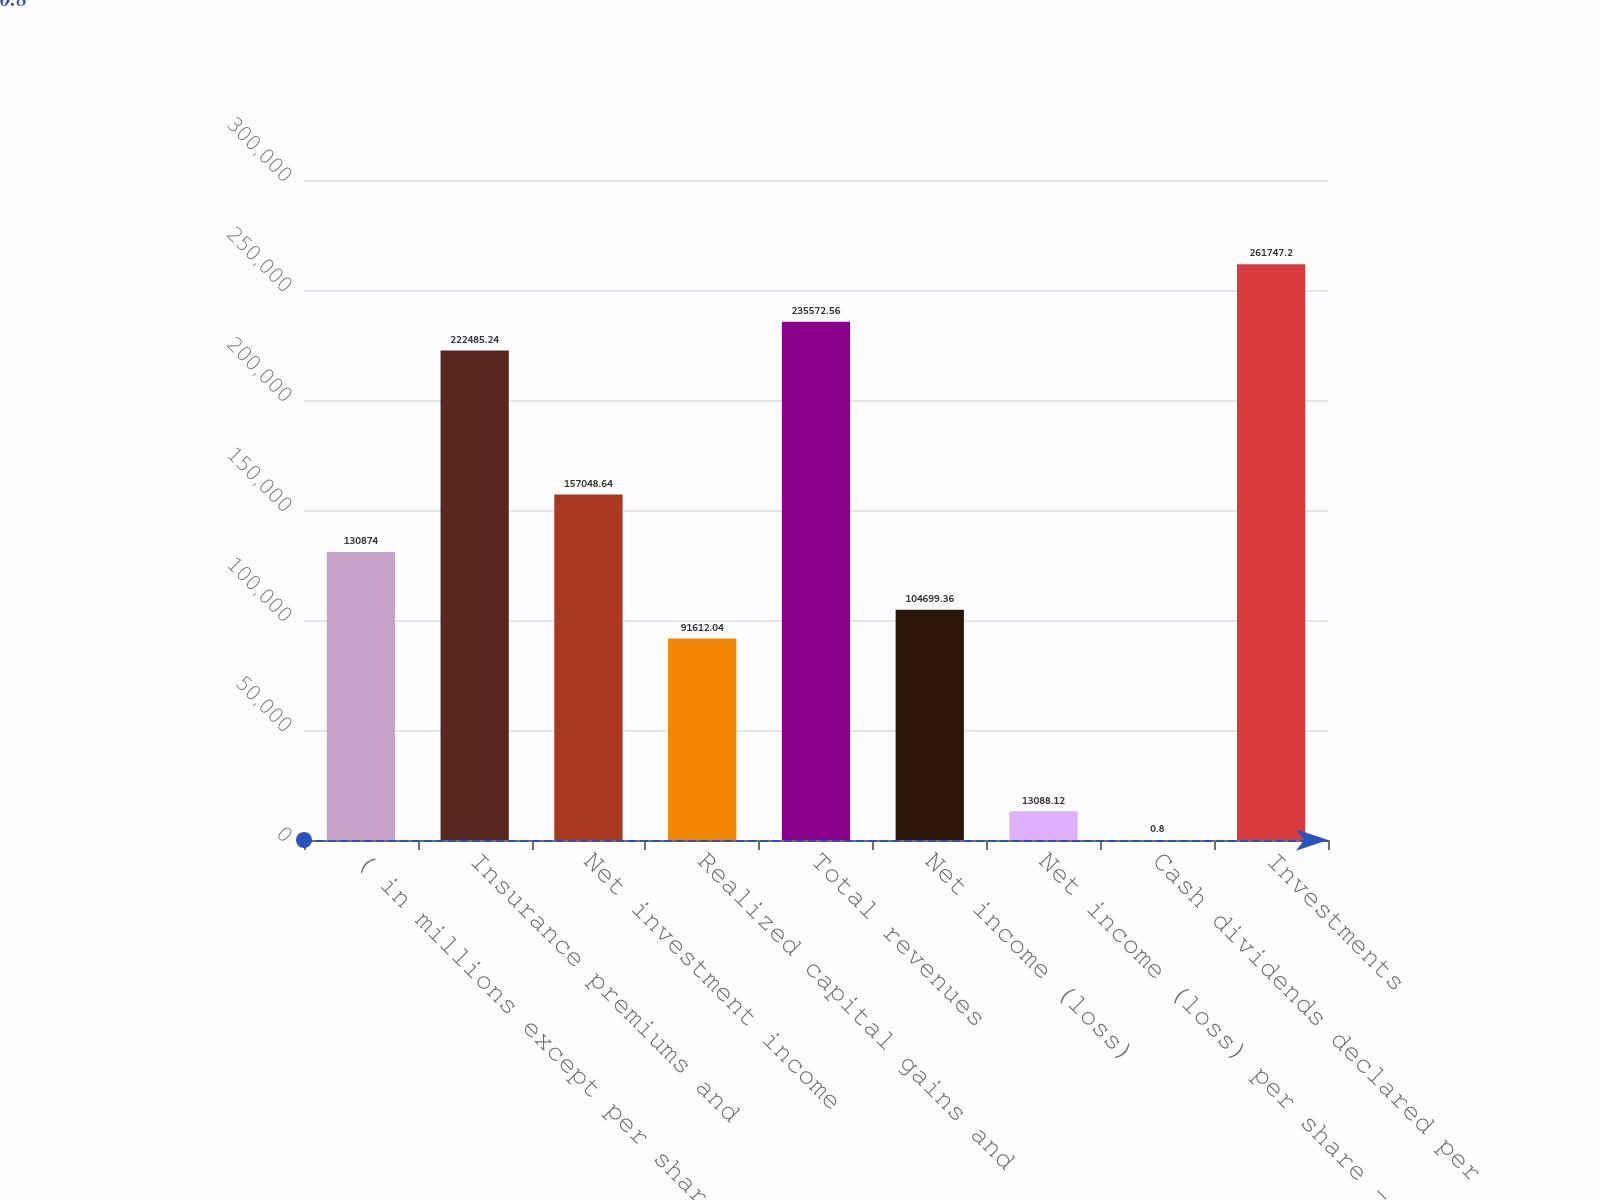Convert chart to OTSL. <chart><loc_0><loc_0><loc_500><loc_500><bar_chart><fcel>( in millions except per share<fcel>Insurance premiums and<fcel>Net investment income<fcel>Realized capital gains and<fcel>Total revenues<fcel>Net income (loss)<fcel>Net income (loss) per share -<fcel>Cash dividends declared per<fcel>Investments<nl><fcel>130874<fcel>222485<fcel>157049<fcel>91612<fcel>235573<fcel>104699<fcel>13088.1<fcel>0.8<fcel>261747<nl></chart> 